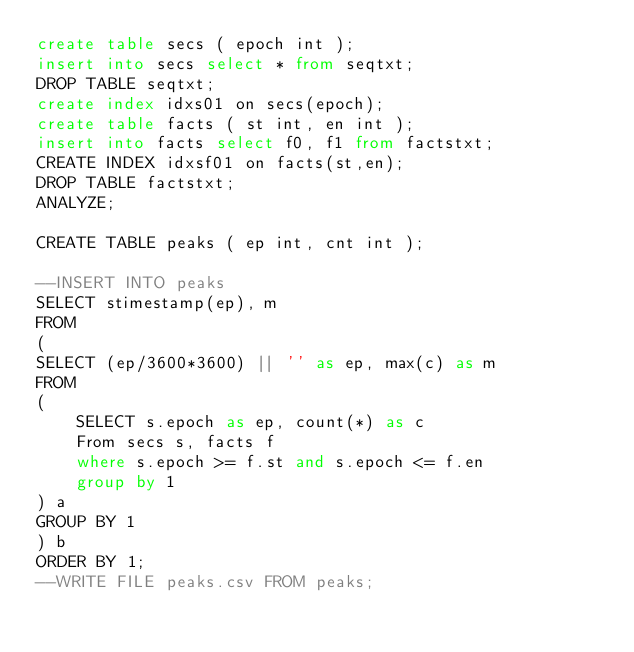Convert code to text. <code><loc_0><loc_0><loc_500><loc_500><_SQL_>create table secs ( epoch int );
insert into secs select * from seqtxt;
DROP TABLE seqtxt;
create index idxs01 on secs(epoch);
create table facts ( st int, en int );
insert into facts select f0, f1 from factstxt;
CREATE INDEX idxsf01 on facts(st,en);
DROP TABLE factstxt;
ANALYZE;

CREATE TABLE peaks ( ep int, cnt int );

--INSERT INTO peaks 
SELECT stimestamp(ep), m
FROM
(
SELECT (ep/3600*3600) || '' as ep, max(c) as m
FROM 
( 
    SELECT s.epoch as ep, count(*) as c
    From secs s, facts f 
    where s.epoch >= f.st and s.epoch <= f.en
    group by 1
) a 
GROUP BY 1 
) b
ORDER BY 1;
--WRITE FILE peaks.csv FROM peaks;

</code> 